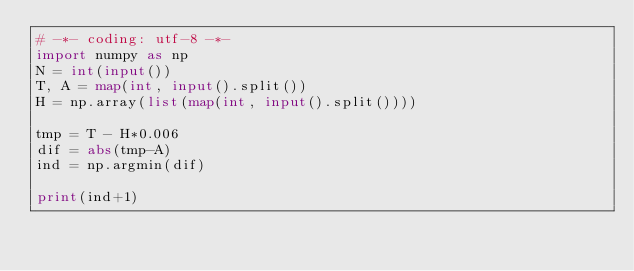<code> <loc_0><loc_0><loc_500><loc_500><_Python_># -*- coding: utf-8 -*-
import numpy as np
N = int(input())
T, A = map(int, input().split())
H = np.array(list(map(int, input().split())))

tmp = T - H*0.006
dif = abs(tmp-A)
ind = np.argmin(dif)

print(ind+1)
</code> 